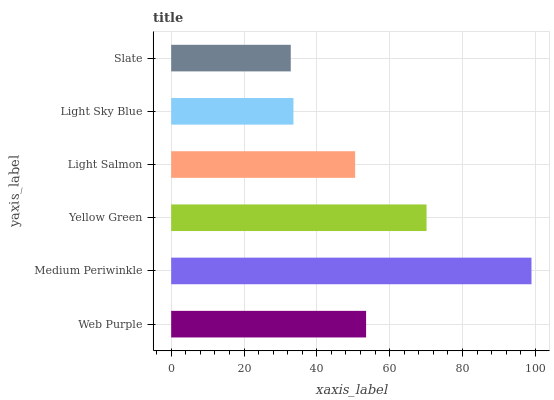Is Slate the minimum?
Answer yes or no. Yes. Is Medium Periwinkle the maximum?
Answer yes or no. Yes. Is Yellow Green the minimum?
Answer yes or no. No. Is Yellow Green the maximum?
Answer yes or no. No. Is Medium Periwinkle greater than Yellow Green?
Answer yes or no. Yes. Is Yellow Green less than Medium Periwinkle?
Answer yes or no. Yes. Is Yellow Green greater than Medium Periwinkle?
Answer yes or no. No. Is Medium Periwinkle less than Yellow Green?
Answer yes or no. No. Is Web Purple the high median?
Answer yes or no. Yes. Is Light Salmon the low median?
Answer yes or no. Yes. Is Yellow Green the high median?
Answer yes or no. No. Is Light Sky Blue the low median?
Answer yes or no. No. 